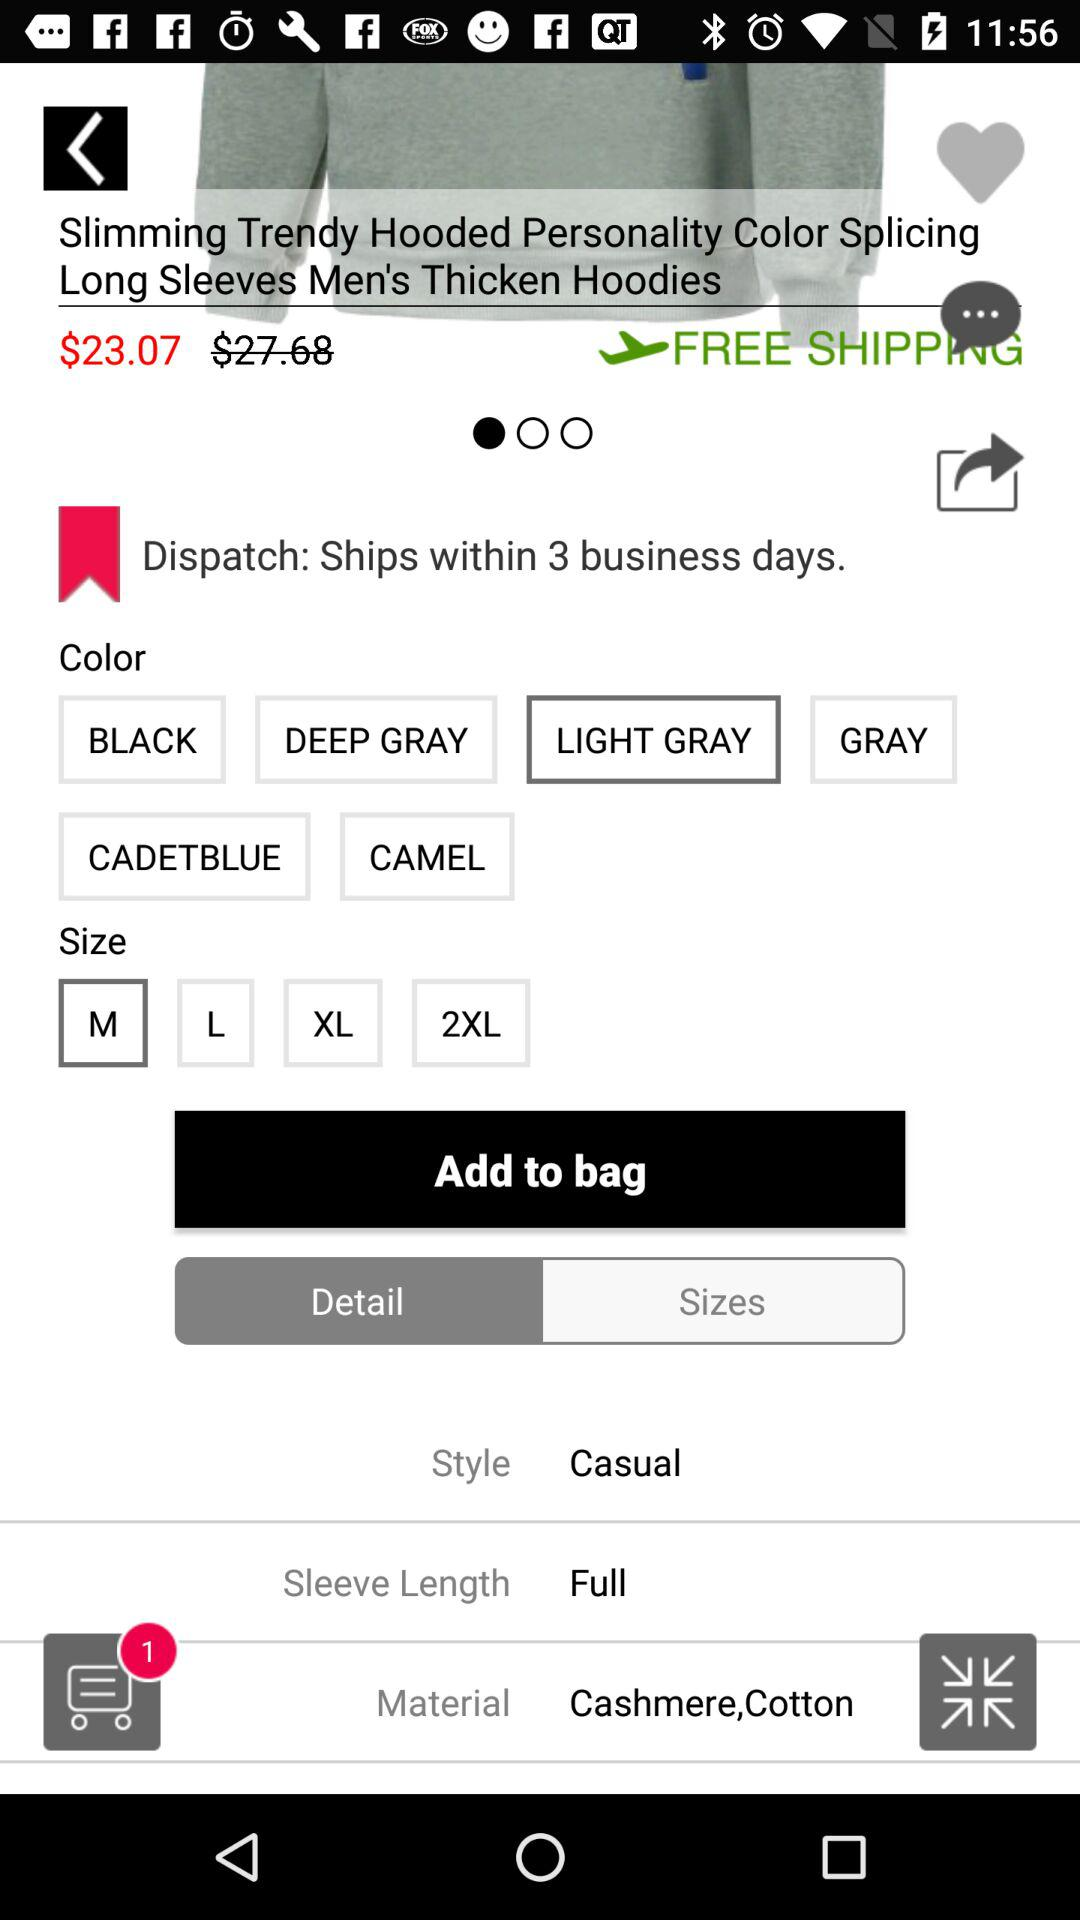What is the sleeve length? The sleeve length is "Full". 